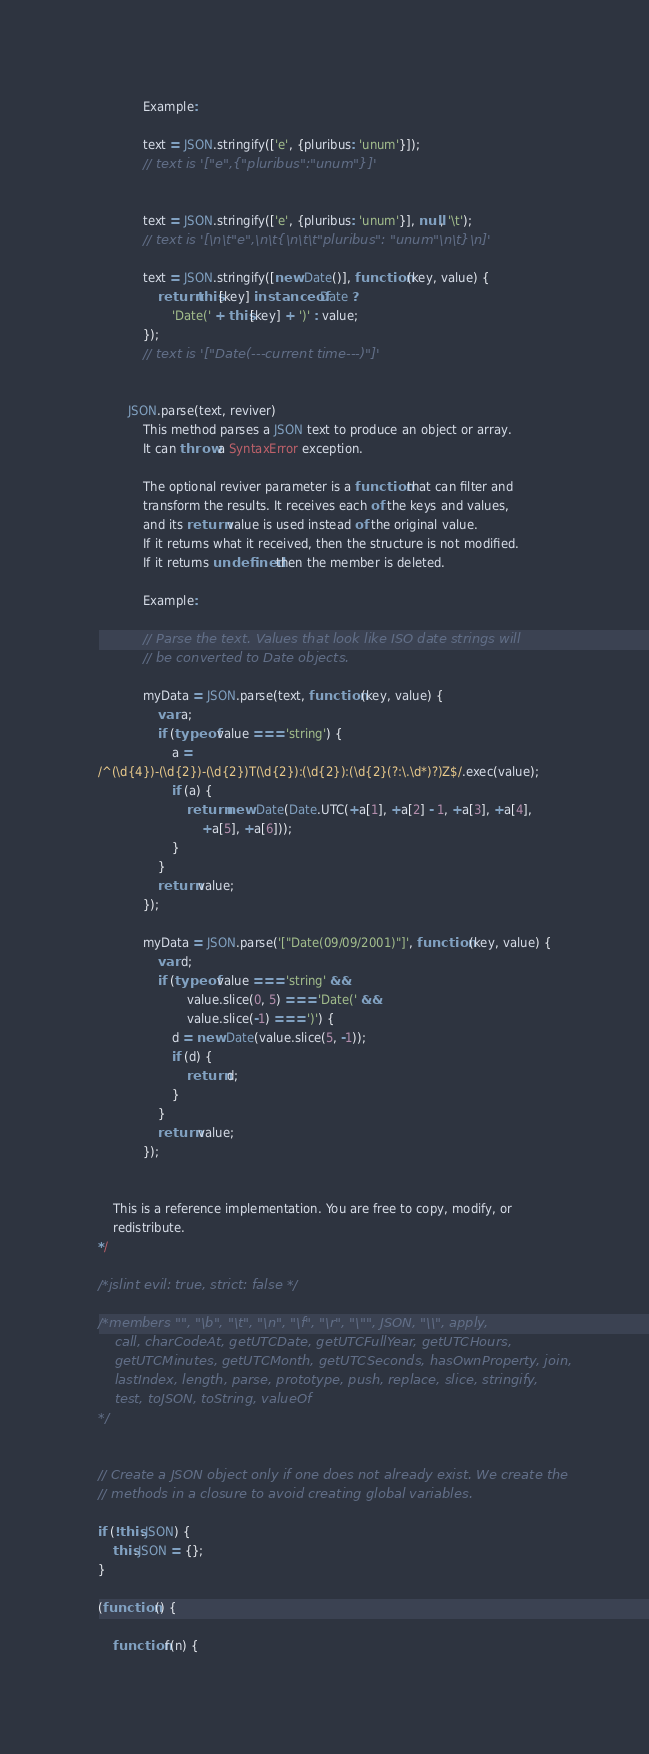<code> <loc_0><loc_0><loc_500><loc_500><_JavaScript_>			Example:

			text = JSON.stringify(['e', {pluribus: 'unum'}]);
			// text is '["e",{"pluribus":"unum"}]'


			text = JSON.stringify(['e', {pluribus: 'unum'}], null, '\t');
			// text is '[\n\t"e",\n\t{\n\t\t"pluribus": "unum"\n\t}\n]'

			text = JSON.stringify([new Date()], function (key, value) {
				return this[key] instanceof Date ?
					'Date(' + this[key] + ')' : value;
			});
			// text is '["Date(---current time---)"]'


		JSON.parse(text, reviver)
			This method parses a JSON text to produce an object or array.
			It can throw a SyntaxError exception.

			The optional reviver parameter is a function that can filter and
			transform the results. It receives each of the keys and values,
			and its return value is used instead of the original value.
			If it returns what it received, then the structure is not modified.
			If it returns undefined then the member is deleted.

			Example:

			// Parse the text. Values that look like ISO date strings will
			// be converted to Date objects.

			myData = JSON.parse(text, function (key, value) {
				var a;
				if (typeof value === 'string') {
					a =
/^(\d{4})-(\d{2})-(\d{2})T(\d{2}):(\d{2}):(\d{2}(?:\.\d*)?)Z$/.exec(value);
					if (a) {
						return new Date(Date.UTC(+a[1], +a[2] - 1, +a[3], +a[4],
							+a[5], +a[6]));
					}
				}
				return value;
			});

			myData = JSON.parse('["Date(09/09/2001)"]', function (key, value) {
				var d;
				if (typeof value === 'string' &&
						value.slice(0, 5) === 'Date(' &&
						value.slice(-1) === ')') {
					d = new Date(value.slice(5, -1));
					if (d) {
						return d;
					}
				}
				return value;
			});


	This is a reference implementation. You are free to copy, modify, or
	redistribute.
*/

/*jslint evil: true, strict: false */

/*members "", "\b", "\t", "\n", "\f", "\r", "\"", JSON, "\\", apply,
	call, charCodeAt, getUTCDate, getUTCFullYear, getUTCHours,
	getUTCMinutes, getUTCMonth, getUTCSeconds, hasOwnProperty, join,
	lastIndex, length, parse, prototype, push, replace, slice, stringify,
	test, toJSON, toString, valueOf
*/


// Create a JSON object only if one does not already exist. We create the
// methods in a closure to avoid creating global variables.

if (!this.JSON) {
	this.JSON = {};
}

(function () {

	function f(n) {</code> 